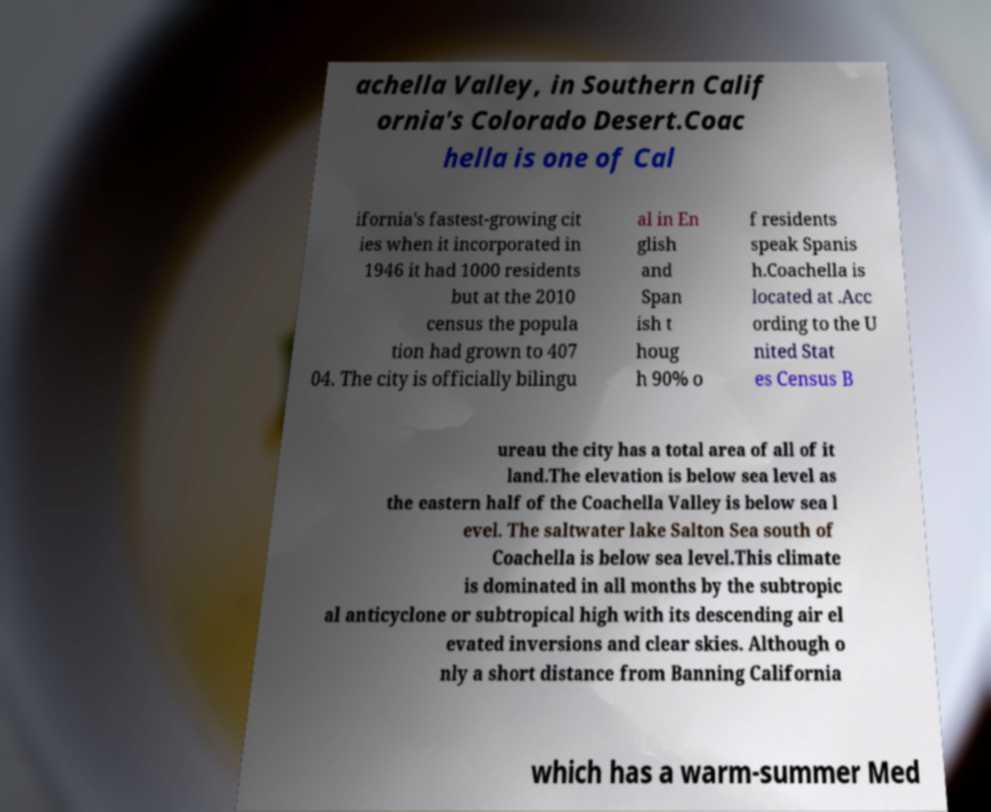Could you extract and type out the text from this image? achella Valley, in Southern Calif ornia's Colorado Desert.Coac hella is one of Cal ifornia's fastest-growing cit ies when it incorporated in 1946 it had 1000 residents but at the 2010 census the popula tion had grown to 407 04. The city is officially bilingu al in En glish and Span ish t houg h 90% o f residents speak Spanis h.Coachella is located at .Acc ording to the U nited Stat es Census B ureau the city has a total area of all of it land.The elevation is below sea level as the eastern half of the Coachella Valley is below sea l evel. The saltwater lake Salton Sea south of Coachella is below sea level.This climate is dominated in all months by the subtropic al anticyclone or subtropical high with its descending air el evated inversions and clear skies. Although o nly a short distance from Banning California which has a warm-summer Med 